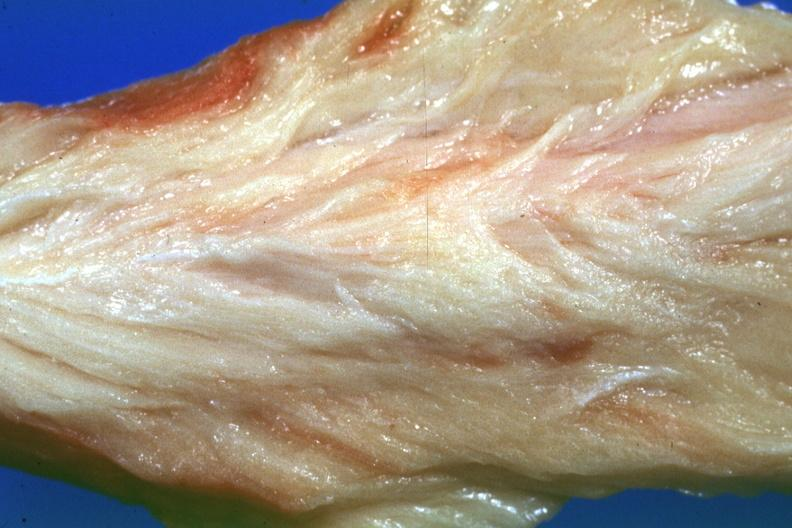does a bulge show close-up very pale muscle?
Answer the question using a single word or phrase. No 